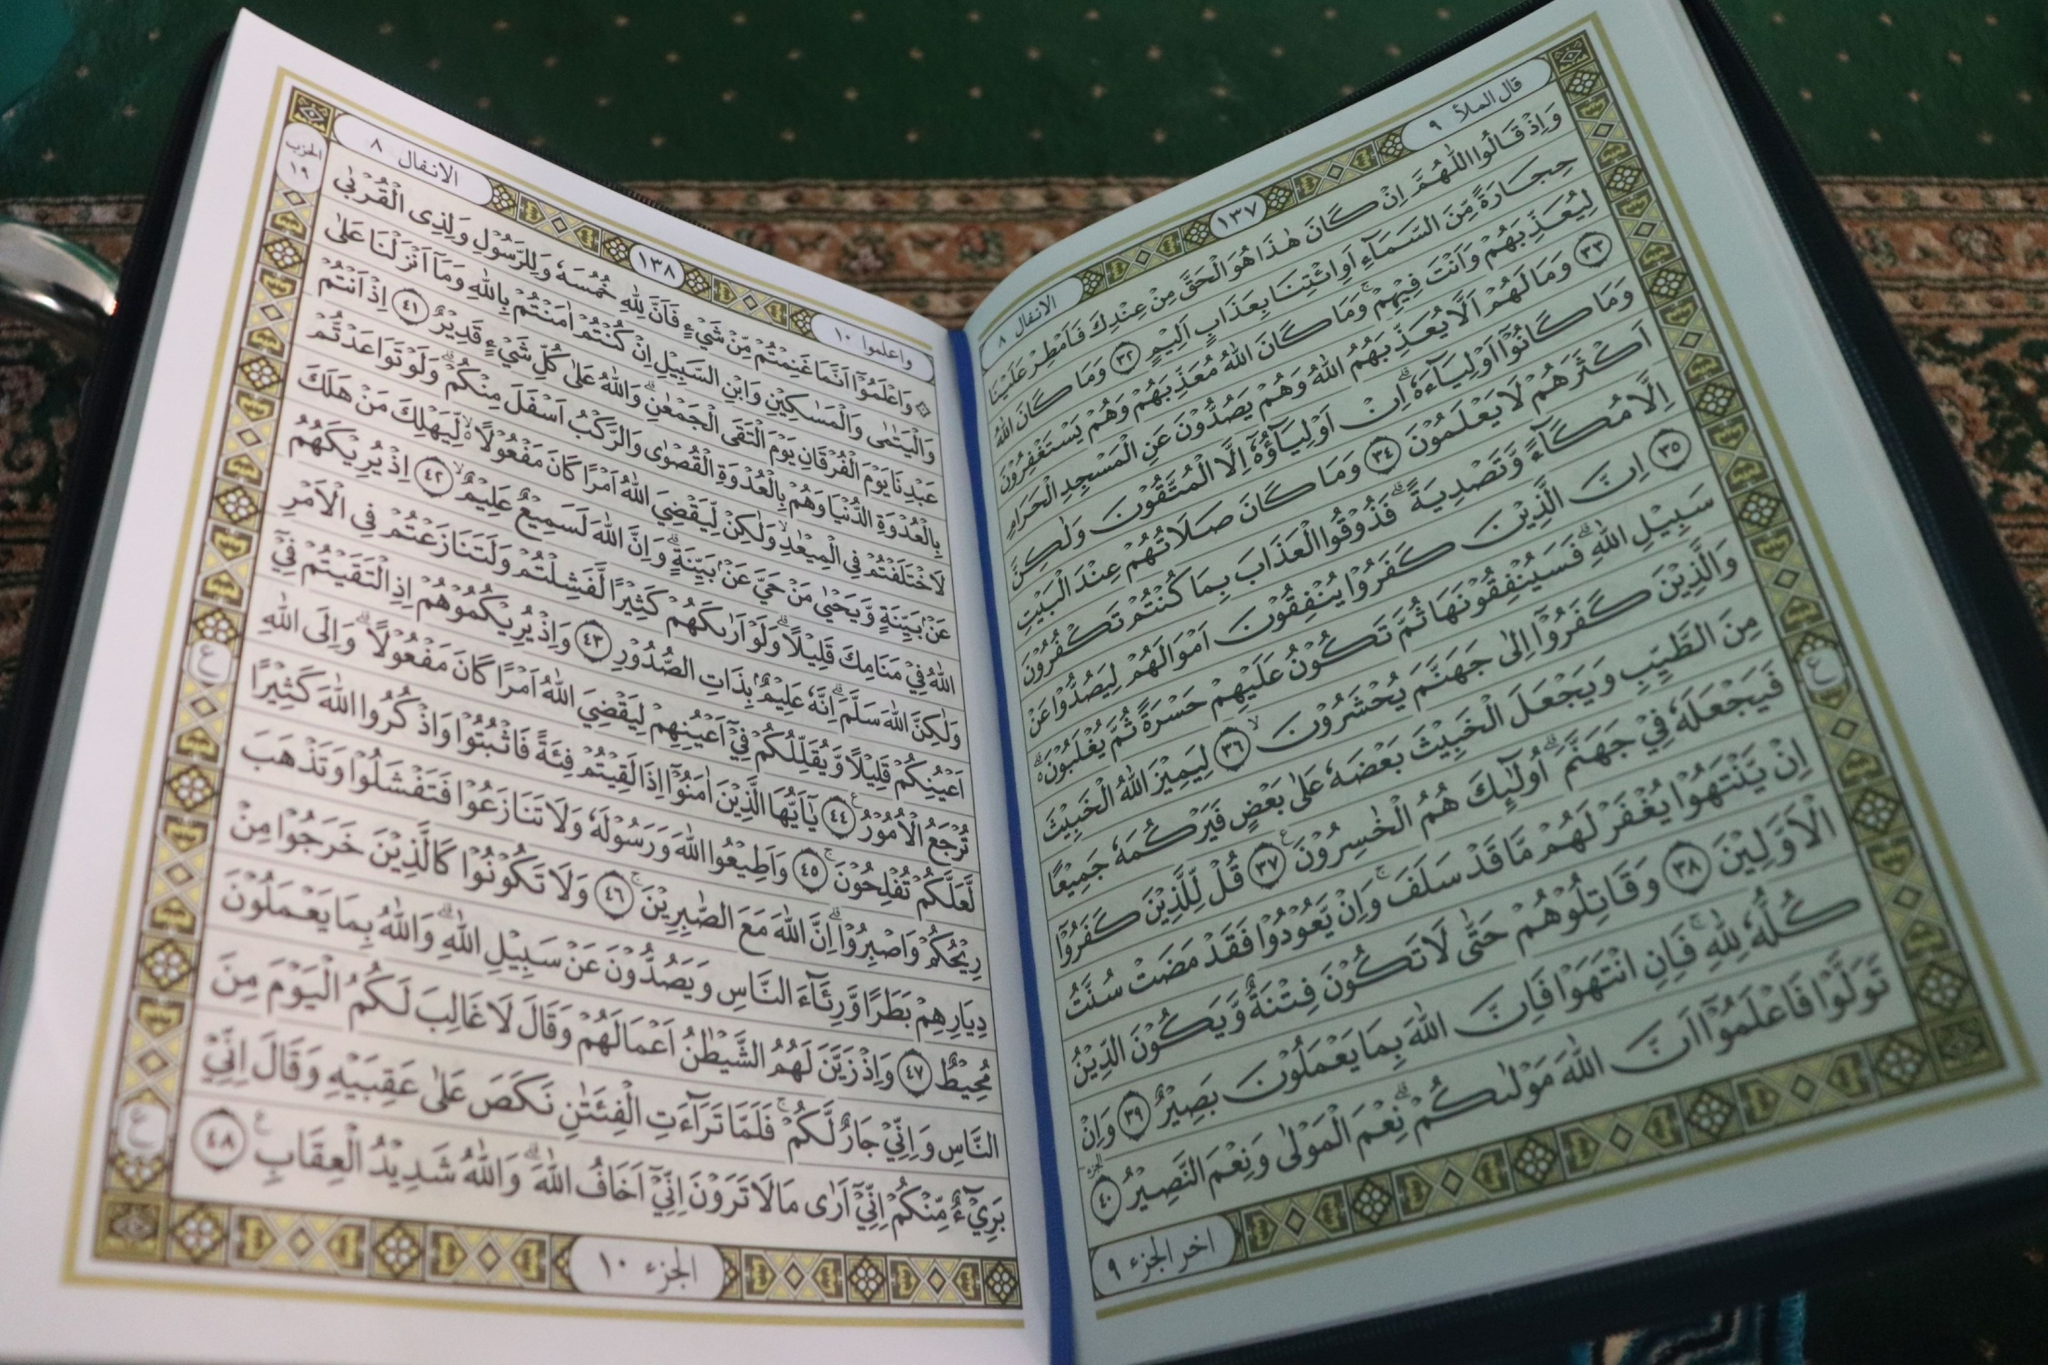Imagine a story about how this book came into being. Long ago, in a serene yet mystical land, there existed a wise and enlightened figure known as Al-Hakim. Al-Hakim was believed to have direct communion with a higher spiritual realm. One night, he received a divine vision delivered by an angel bathed in ethereal light. The angel entrusted Al-Hakim with sacred knowledge and the mission to compile this wisdom into a book that would guide humanity with teachings of love, compassion, justice, and truth. Over the years, in seclusion, Al-Hakim meticulously transcribed this divine wisdom onto parchment using golden ink, embedding each page with intricate calligraphy and celestial patterns to reflect its heavenly origin. The book was then guarded and revered by generations, becoming a beacon of spiritual enlightenment for all who sought its teachings. 